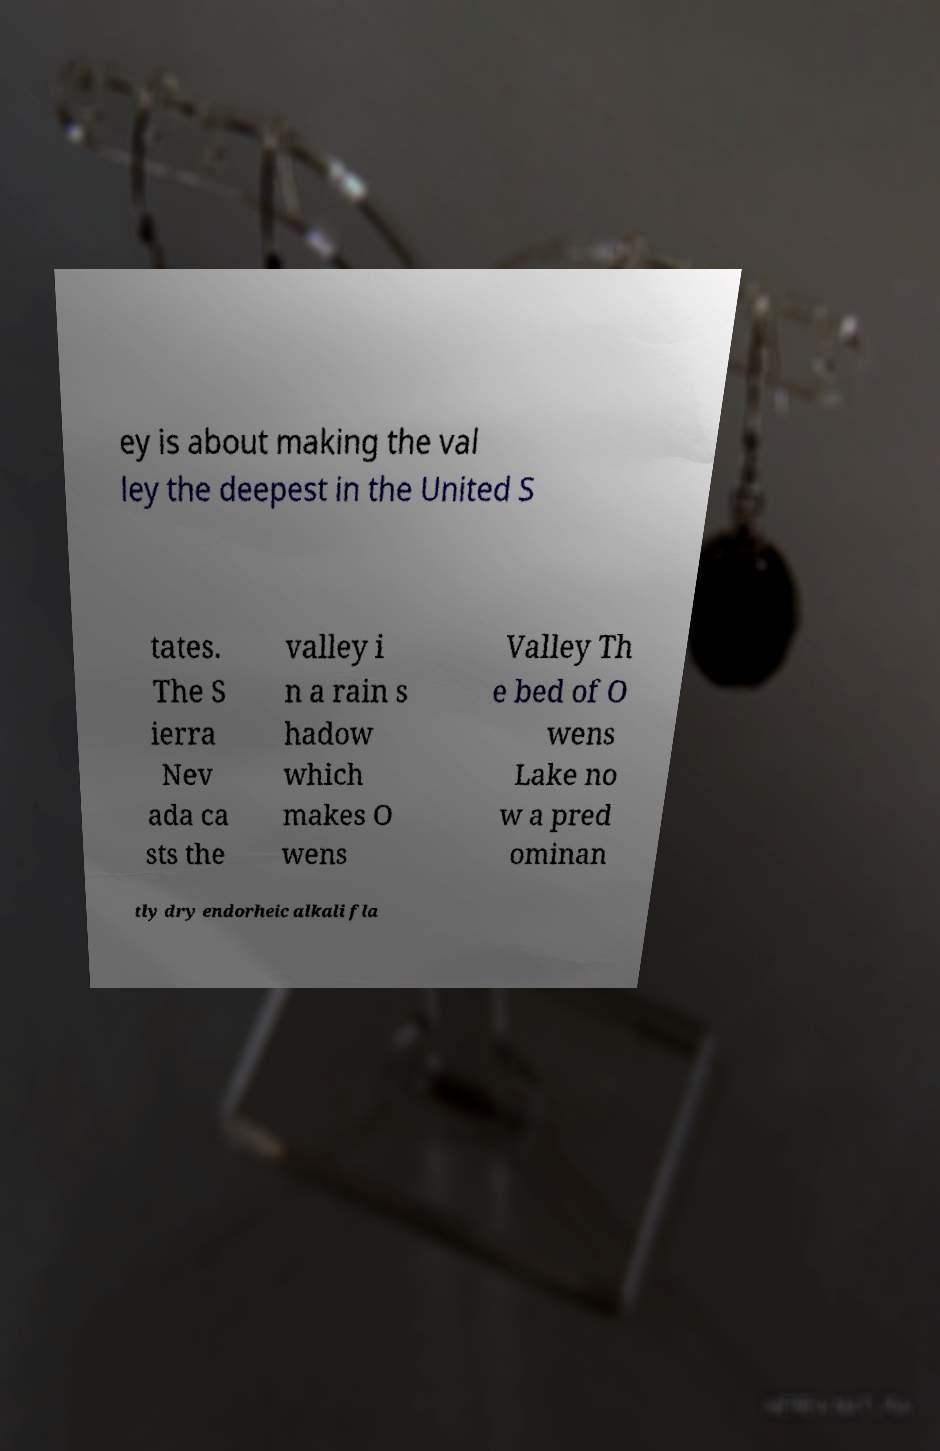Please identify and transcribe the text found in this image. ey is about making the val ley the deepest in the United S tates. The S ierra Nev ada ca sts the valley i n a rain s hadow which makes O wens Valley Th e bed of O wens Lake no w a pred ominan tly dry endorheic alkali fla 